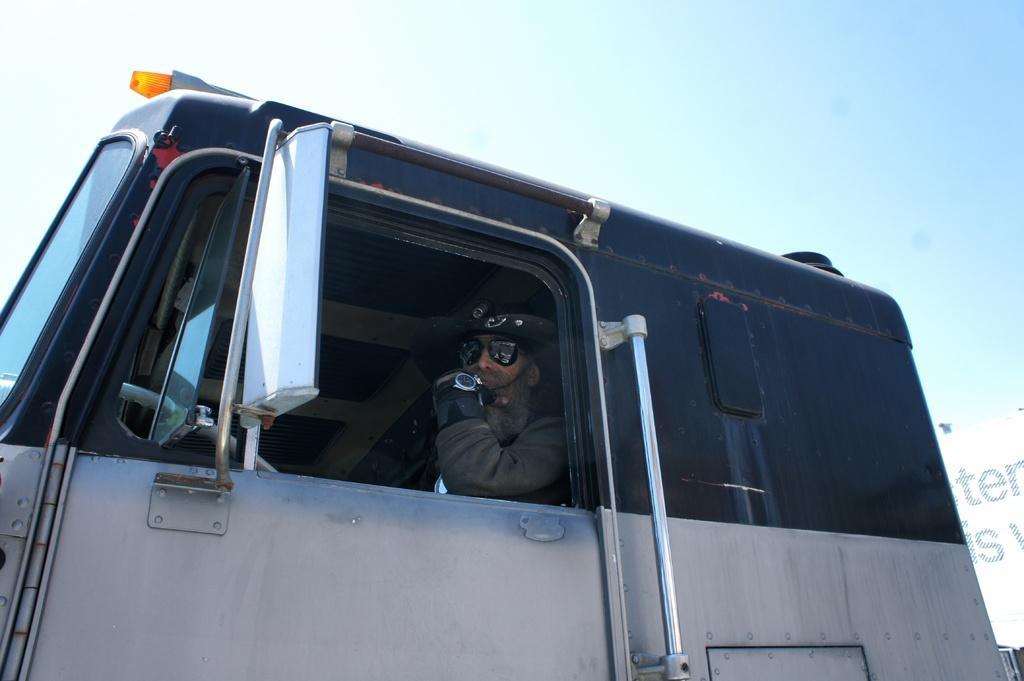Can you describe this image briefly? In this picture, we see a man riding the vehicle. He is wearing the goggles and a watch. He is in the uniform. This vehicle is in black and white color. On the right side, we see a board or a banner in white color with some text written on it. At the top of the picture, we see the sky. 